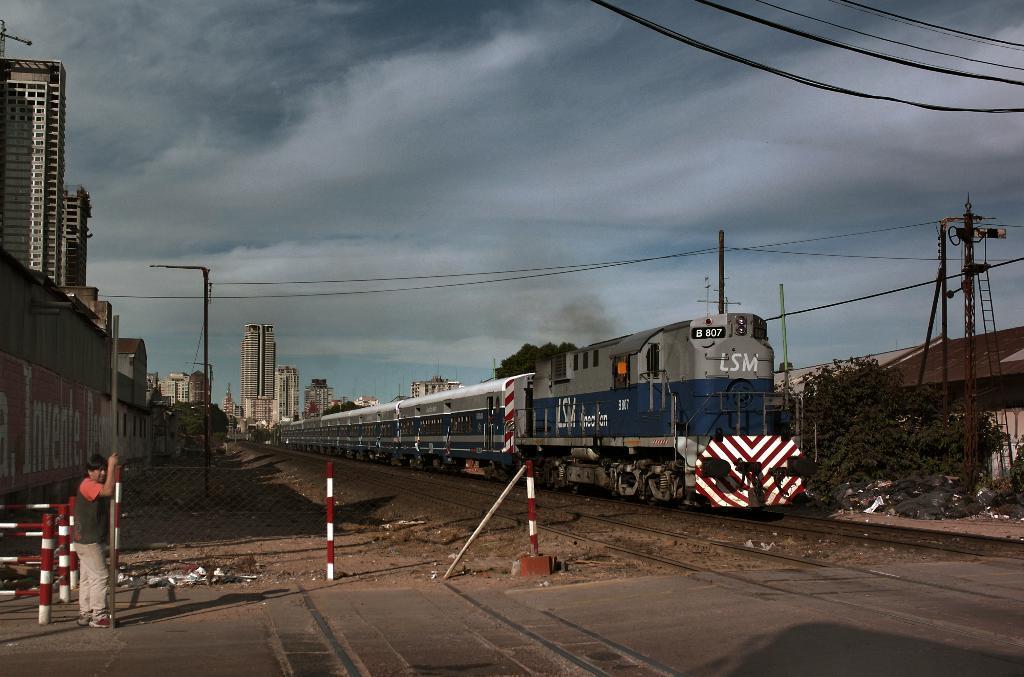Could you give a brief overview of what you see in this image? At the bottom we can see a road and on the left a person is standing on the road by holding a pole and we can also see fence and poles. In the background there is a train moving on a railway track and we can also see buildings,trees,poles and clouds in the sky. 